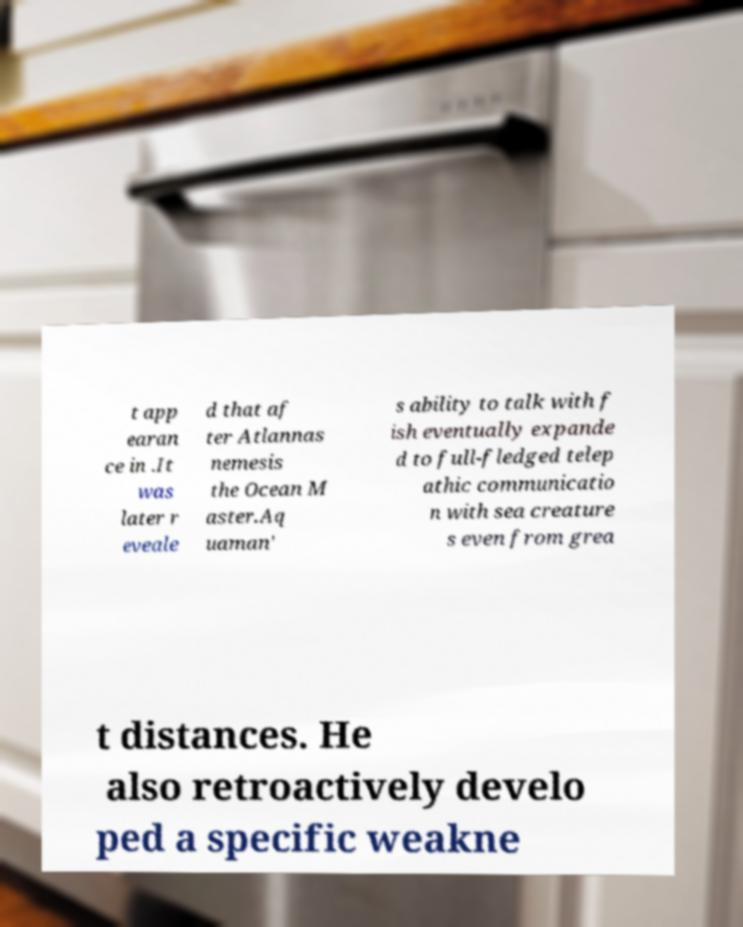I need the written content from this picture converted into text. Can you do that? t app earan ce in .It was later r eveale d that af ter Atlannas nemesis the Ocean M aster.Aq uaman' s ability to talk with f ish eventually expande d to full-fledged telep athic communicatio n with sea creature s even from grea t distances. He also retroactively develo ped a specific weakne 